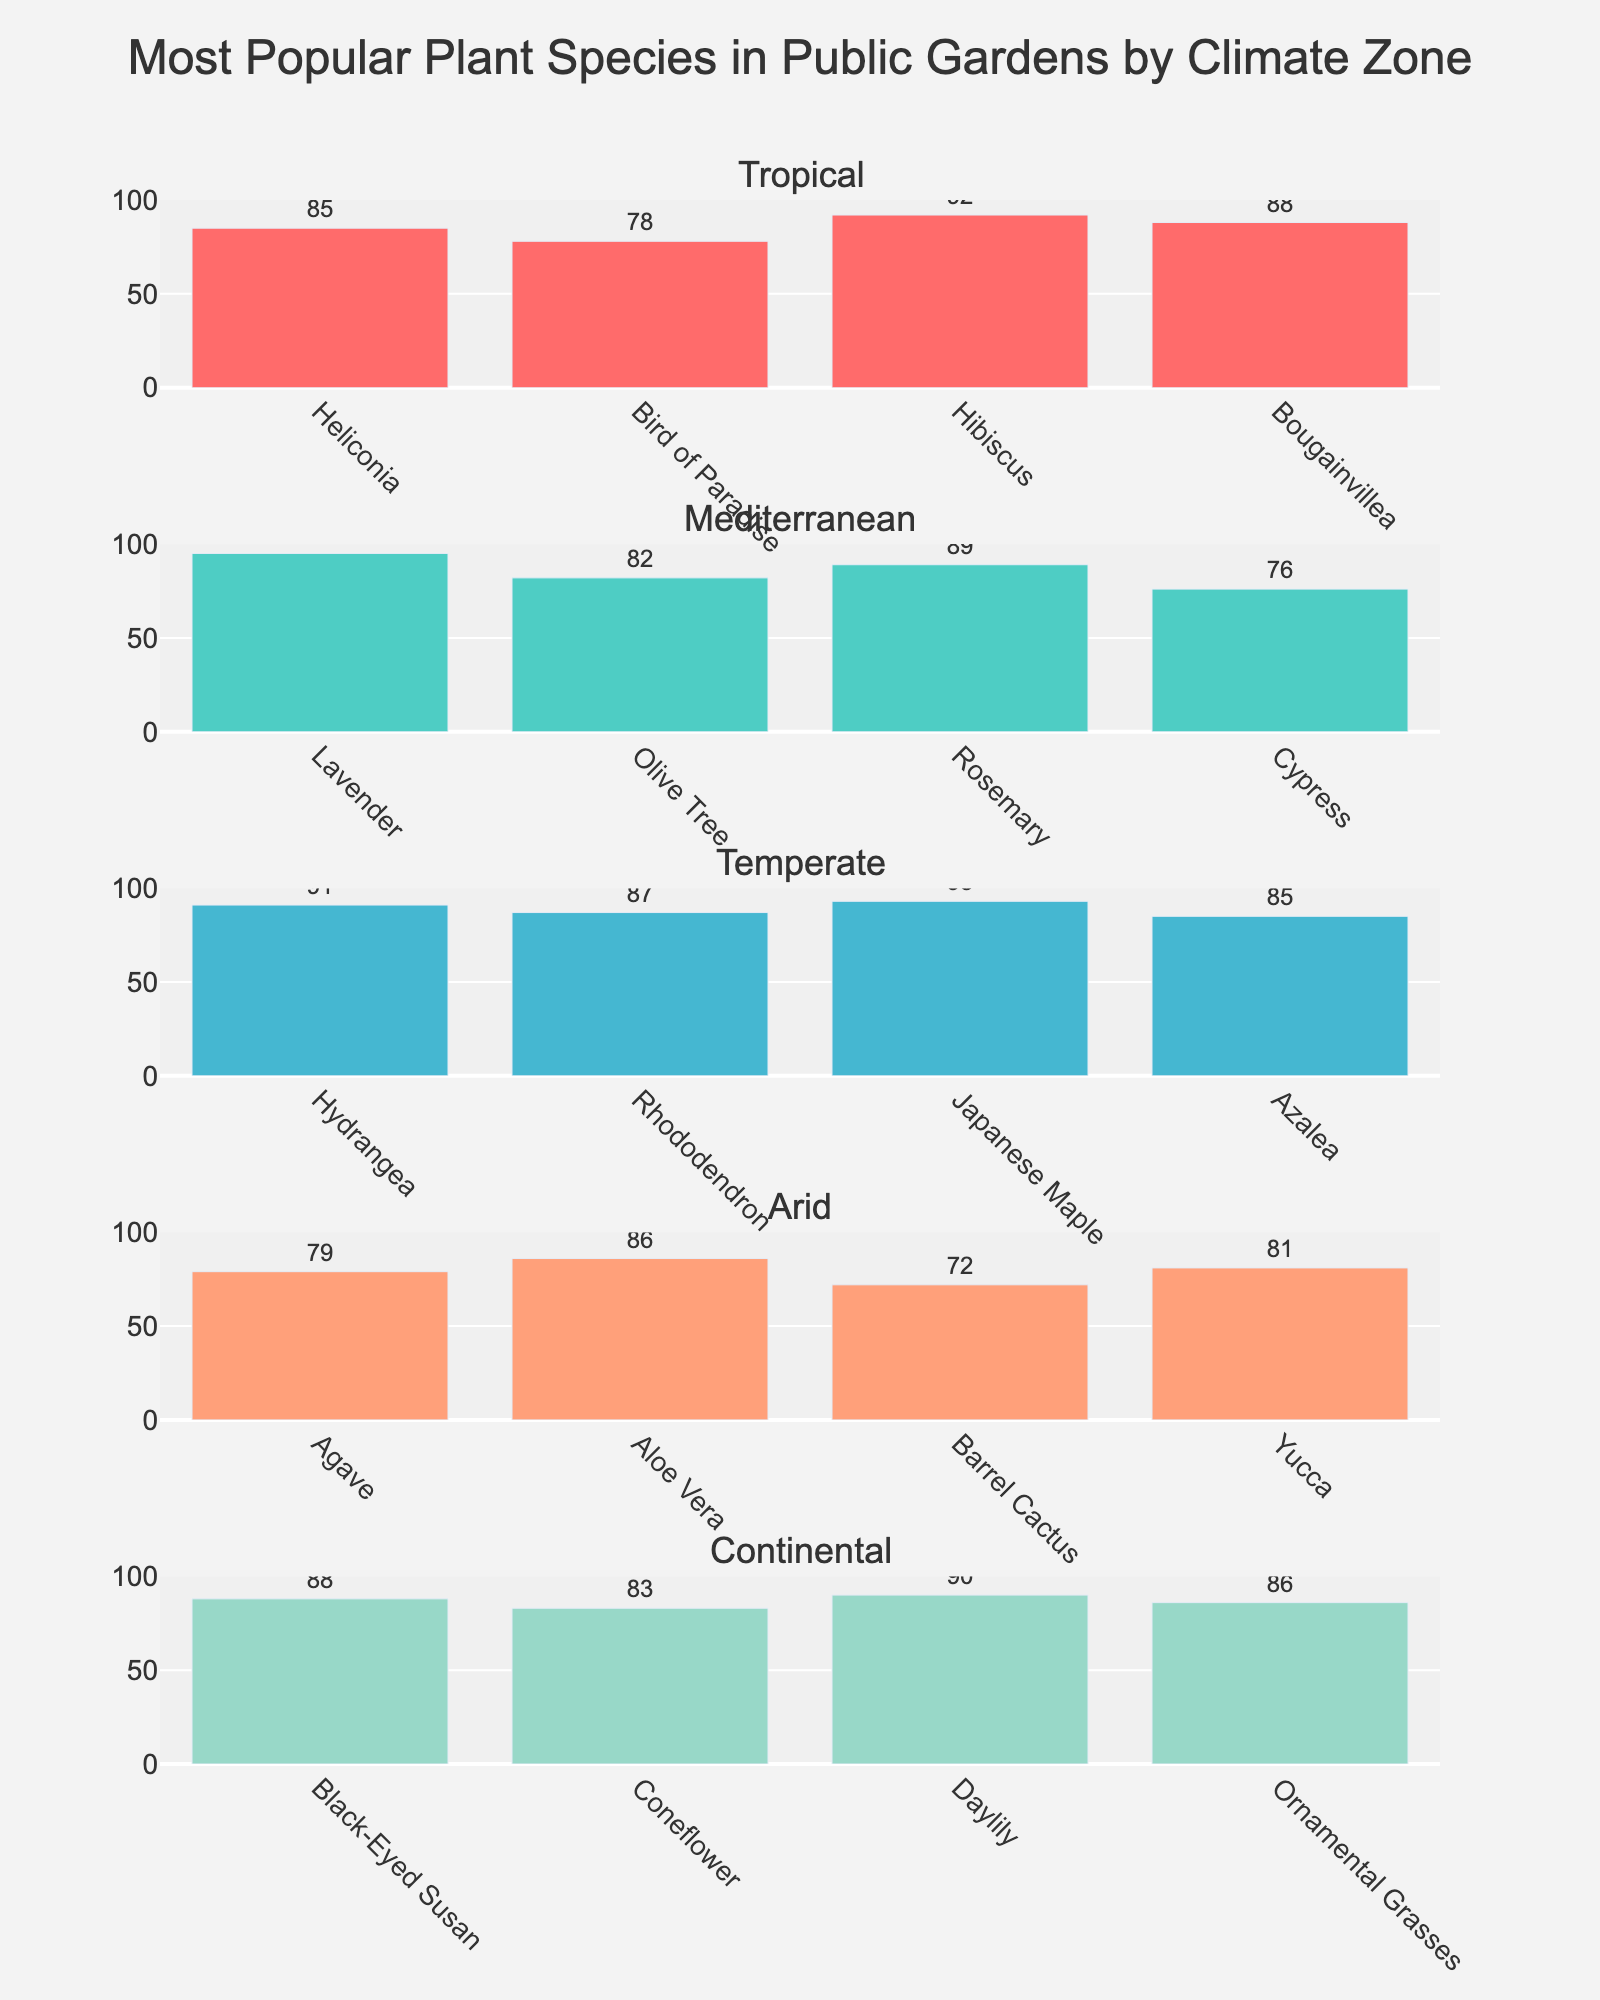What's the most popular plant species in the Tropical climate zone? Look at the "Tropical" subplot and identify the bar with the highest value. The "Hibiscus" bar is the tallest with a popularity score of 92.
Answer: Hibiscus Which climate zone has the plant species with the highest popularity score? Compare the highest bars in each climate zone. The "Mediterranean" subplot has the highest bar for "Lavender" with a score of 95.
Answer: Mediterranean What's the average popularity score of plant species in the Arid climate zone? Add the popularity scores in the "Arid" subplot (79 + 86 + 72 + 81) and divide by 4. (79 + 86 + 72 + 81 = 318, 318 / 4 = 79.5)
Answer: 79.5 Which plant species in the Temperate climate zone has the lowest popularity score? Look at the "Temperate" subplot and find the shortest bar. The "Rhododendron" bar has the lowest score of 87.
Answer: Rhododendron How much higher is the popularity score of the Japanese Maple compared to the Azalea in the Temperate climate zone? Subtract the popularity score of the Azalea (85) from the Japanese Maple (93). (93 - 85 = 8)
Answer: 8 What's the total popularity score of all plant species in the Continental climate zone? Add the popularity scores in the "Continental" subplot (88 + 83 + 90 + 86). (88 + 83 + 90 + 86 = 347)
Answer: 347 Which plant species has the highest popularity score in the Mediterranean climate zone? Look at the "Mediterranean" subplot and identify the bar with the highest value. The "Lavender" bar is the tallest with a popularity score of 95.
Answer: Lavender Compare the popularity scores of Heliconia and Bird of Paradise in the Tropical climate zone. Which one is more popular and by how much? Subtract the popularity score of Bird of Paradise (78) from Heliconia (85). (85 - 78 = 7). Heliconia is more popular by 7 points.
Answer: Heliconia, 7 What's the difference in popularity scores between the Olive Tree and the Daylily? Subtract the popularity score of Olive Tree (82) from the Daylily (90). (90 - 82 = 8)
Answer: 8 